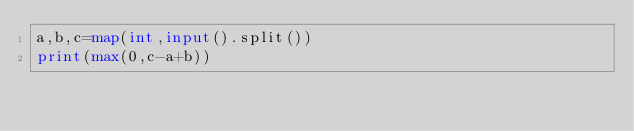Convert code to text. <code><loc_0><loc_0><loc_500><loc_500><_Python_>a,b,c=map(int,input().split())
print(max(0,c-a+b))</code> 